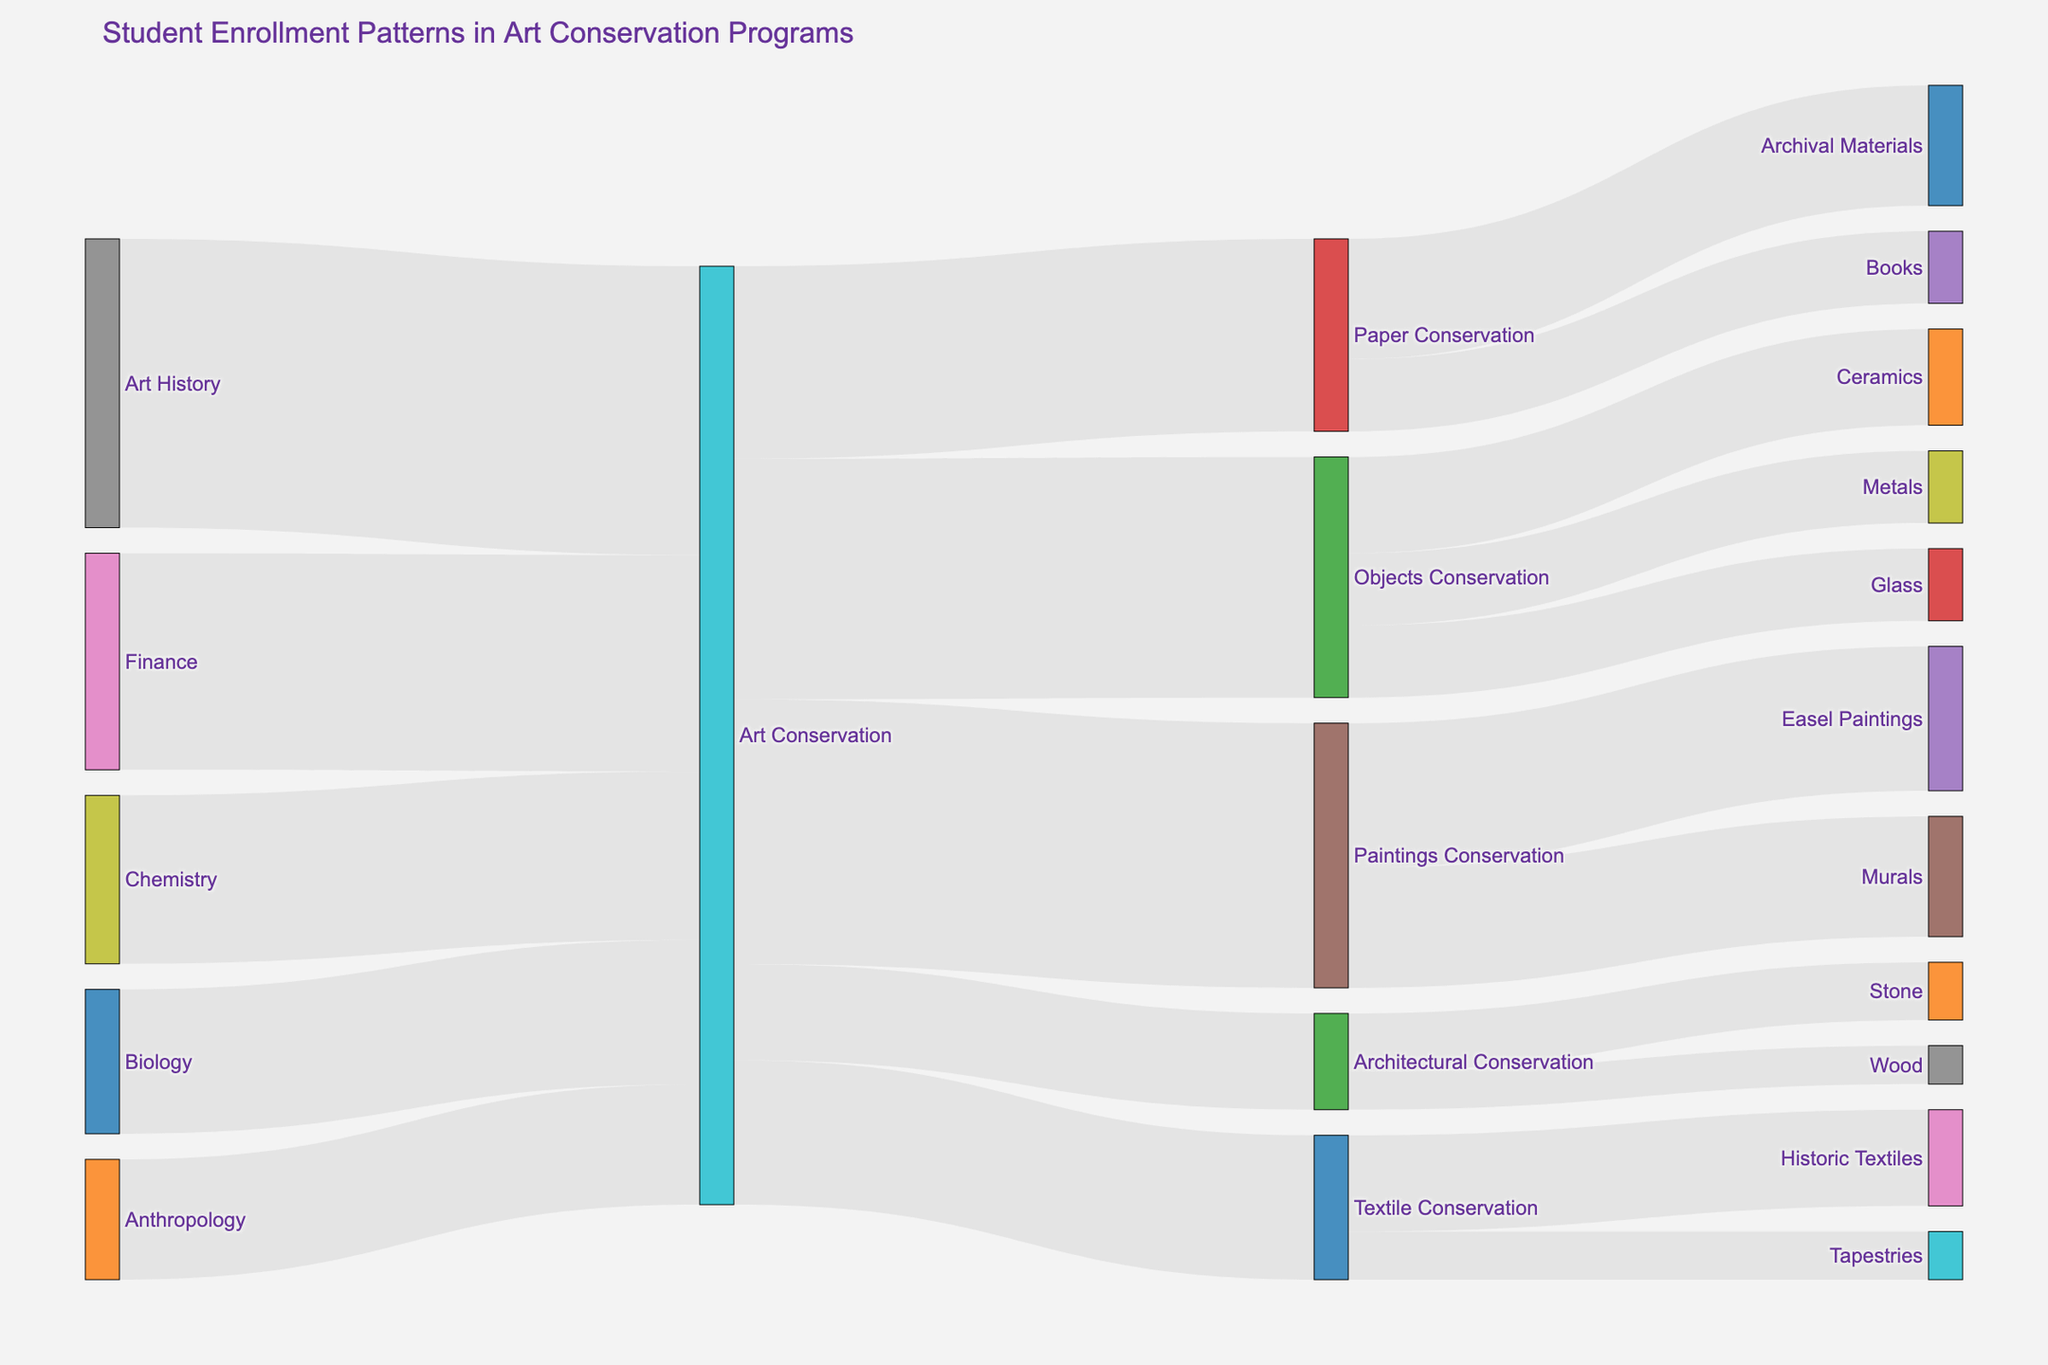What is the title of the figure? The title is displayed at the top of the figure. It is "Student Enrollment Patterns in Art Conservation Programs".
Answer: Student Enrollment Patterns in Art Conservation Programs How many students have a background in Chemistry? By examining the Sankey diagram, we can see the flow from Chemistry to Art Conservation that shows the number 35.
Answer: 35 Which specialization within Paintings Conservation has more students, Easel Paintings or Murals? By tracing the flows from Paintings Conservation to both Easel Paintings and Murals, we observe that Easel Paintings has 30 students, while Murals has 25 students.
Answer: Easel Paintings What is the total number of students in Paper Conservation specializations? Add the values for Archival Materials and Books under Paper Conservation specializations: 25 (Archival Materials) + 15 (Books).
Answer: 40 What proportion of Art History students specialize in Paintings Conservation? First, identify the total number of Art History students entering Art Conservation, which is 60. Then, follow the flow from Art Conservation to Paintings Conservation where it is shown there are 55 students. Calculate the proportion: 55/60.
Answer: 55/60 or approximately 0.92 How many more students specialize in Objects Conservation than in Textile Conservation? Count the number of students in Objects Conservation (50) and Textile Conservation (30) and take the difference: 50 - 30.
Answer: 20 Which previous educational background has the highest number of students? By observing the starting points (backgrounds), we find the flow from Art History is the largest, with 60 students.
Answer: Art History What is the total number of students entering Art Conservation from non-Art backgrounds (Finance, Biology, Chemistry, Anthropology)? Add the values for students from Finance, Biology, Chemistry, and Anthropology: 45 + 30 + 35 + 25.
Answer: 135 How many specializations are available within Art Conservation in the Sankey diagram? Count all the target specializations under Art Conservation (Paintings Conservation, Objects Conservation, Paper Conservation, Textile Conservation, Architectural Conservation).
Answer: 5 What is the flow ratio between Metal and Glass specializations in Objects Conservation? Identify the flows from Objects Conservation to Metals (15) and Glass (15). The ratio is 15:15 or simplified, 1:1.
Answer: 1:1 What percentage of all Art Conservation students specialize in Architectural Conservation? Calculate the total number of Art Conservation students by summing inputs (45+30+35+60+25 = 195). Then, find the number specializing in Architectural Conservation (20), and use the formula \( \frac{20}{195} \times 100 \).
Answer: Approximately 10.26% 